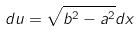<formula> <loc_0><loc_0><loc_500><loc_500>d u = \sqrt { b ^ { 2 } - a ^ { 2 } } d x</formula> 